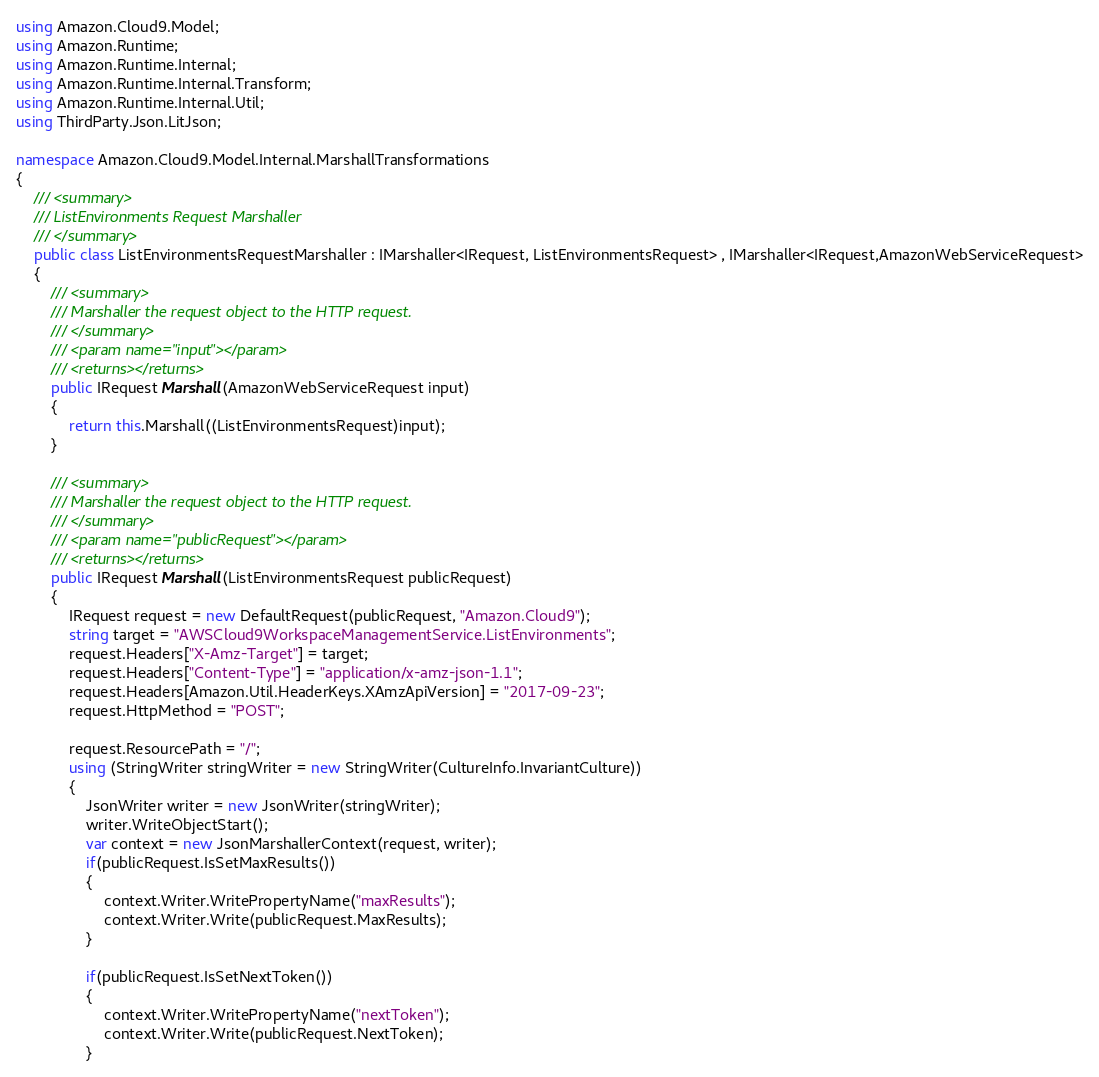<code> <loc_0><loc_0><loc_500><loc_500><_C#_>
using Amazon.Cloud9.Model;
using Amazon.Runtime;
using Amazon.Runtime.Internal;
using Amazon.Runtime.Internal.Transform;
using Amazon.Runtime.Internal.Util;
using ThirdParty.Json.LitJson;

namespace Amazon.Cloud9.Model.Internal.MarshallTransformations
{
    /// <summary>
    /// ListEnvironments Request Marshaller
    /// </summary>       
    public class ListEnvironmentsRequestMarshaller : IMarshaller<IRequest, ListEnvironmentsRequest> , IMarshaller<IRequest,AmazonWebServiceRequest>
    {
        /// <summary>
        /// Marshaller the request object to the HTTP request.
        /// </summary>  
        /// <param name="input"></param>
        /// <returns></returns>
        public IRequest Marshall(AmazonWebServiceRequest input)
        {
            return this.Marshall((ListEnvironmentsRequest)input);
        }

        /// <summary>
        /// Marshaller the request object to the HTTP request.
        /// </summary>  
        /// <param name="publicRequest"></param>
        /// <returns></returns>
        public IRequest Marshall(ListEnvironmentsRequest publicRequest)
        {
            IRequest request = new DefaultRequest(publicRequest, "Amazon.Cloud9");
            string target = "AWSCloud9WorkspaceManagementService.ListEnvironments";
            request.Headers["X-Amz-Target"] = target;
            request.Headers["Content-Type"] = "application/x-amz-json-1.1";
            request.Headers[Amazon.Util.HeaderKeys.XAmzApiVersion] = "2017-09-23";
            request.HttpMethod = "POST";

            request.ResourcePath = "/";
            using (StringWriter stringWriter = new StringWriter(CultureInfo.InvariantCulture))
            {
                JsonWriter writer = new JsonWriter(stringWriter);
                writer.WriteObjectStart();
                var context = new JsonMarshallerContext(request, writer);
                if(publicRequest.IsSetMaxResults())
                {
                    context.Writer.WritePropertyName("maxResults");
                    context.Writer.Write(publicRequest.MaxResults);
                }

                if(publicRequest.IsSetNextToken())
                {
                    context.Writer.WritePropertyName("nextToken");
                    context.Writer.Write(publicRequest.NextToken);
                }
</code> 